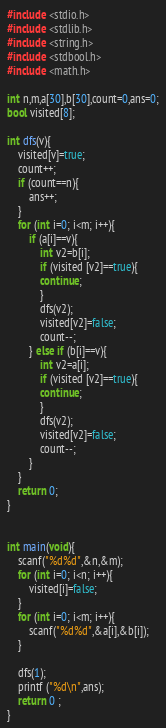<code> <loc_0><loc_0><loc_500><loc_500><_C_>#include <stdio.h>
#include <stdlib.h>
#include <string.h>
#include <stdbool.h>
#include <math.h>

int n,m,a[30],b[30],count=0,ans=0;
bool visited[8];

int dfs(v){
    visited[v]=true;
    count++;
    if (count==n){
        ans++;
    }
    for (int i=0; i<m; i++){
        if (a[i]==v){
            int v2=b[i];
            if (visited [v2]==true){
            continue;
            }
            dfs(v2);
            visited[v2]=false;
            count--;
        } else if (b[i]==v){
            int v2=a[i];
            if (visited [v2]==true){
            continue;
            }
            dfs(v2);
            visited[v2]=false;
            count--;
        }
    }
    return 0;
}


int main(void){
    scanf("%d%d",&n,&m);
    for (int i=0; i<n; i++){
        visited[i]=false;
    }
    for (int i=0; i<m; i++){
        scanf("%d%d",&a[i],&b[i]);
    }
    
    dfs(1);
    printf ("%d\n",ans);
	return 0 ;
}</code> 